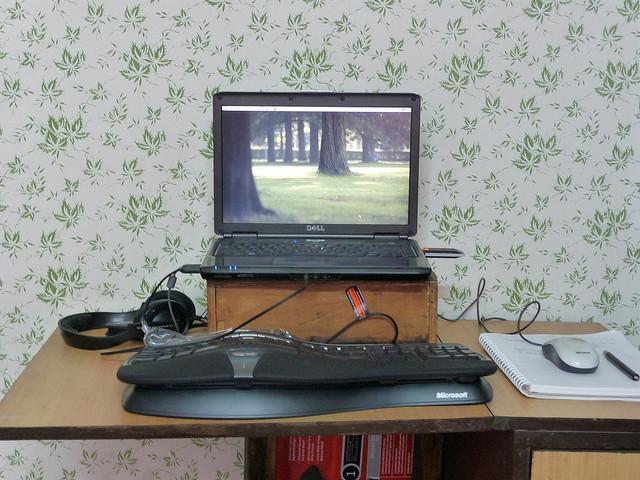How many time-telling devices are on this desk?
Give a very brief answer. 1. 